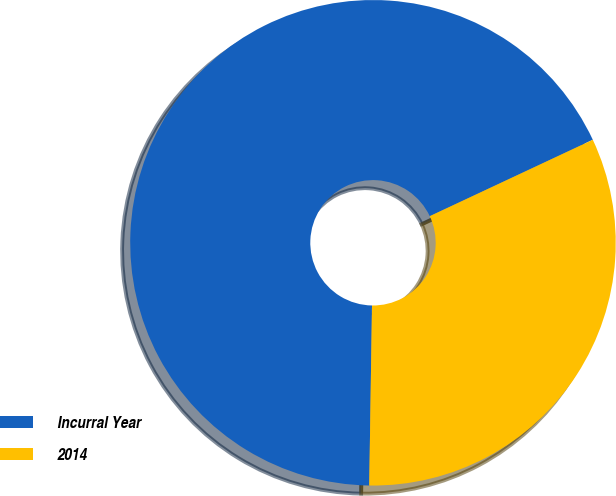Convert chart to OTSL. <chart><loc_0><loc_0><loc_500><loc_500><pie_chart><fcel>Incurral Year<fcel>2014<nl><fcel>67.78%<fcel>32.22%<nl></chart> 